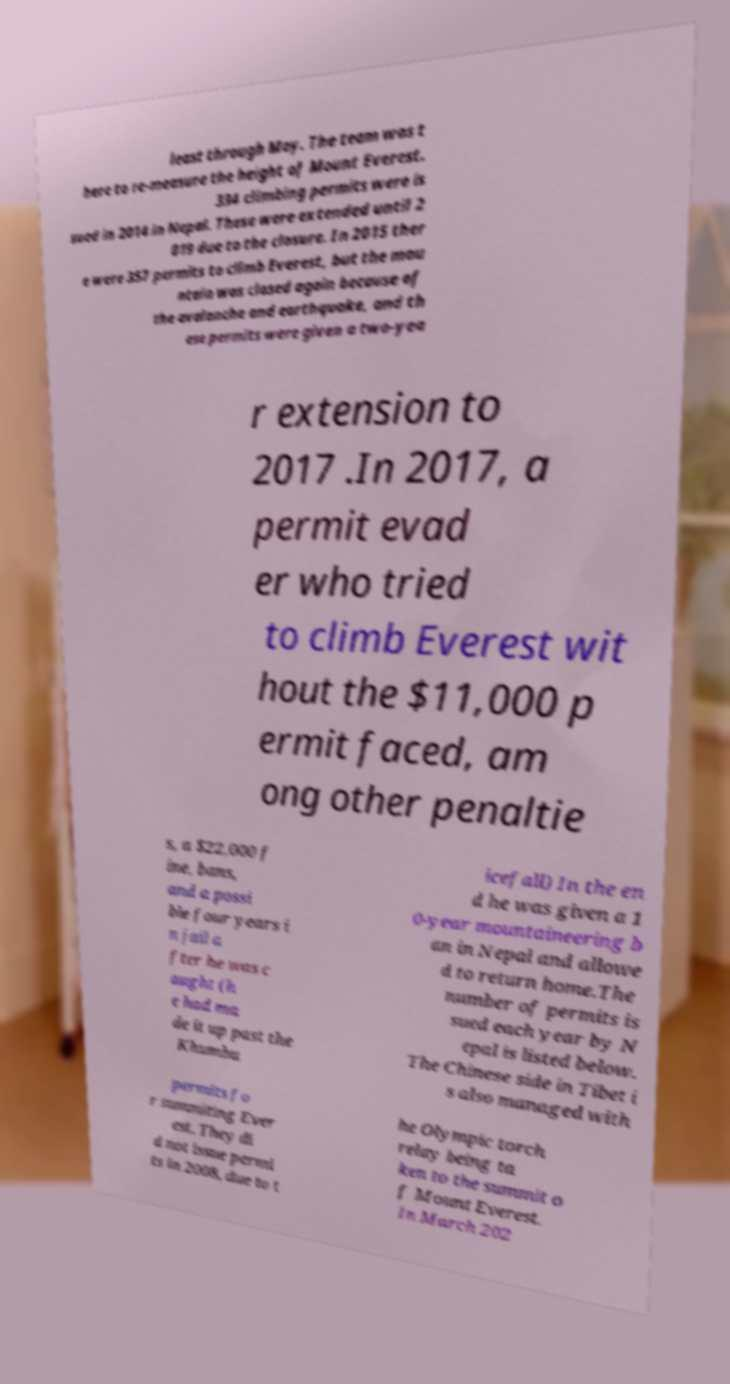Please identify and transcribe the text found in this image. least through May. The team was t here to re-measure the height of Mount Everest. 334 climbing permits were is sued in 2014 in Nepal. These were extended until 2 019 due to the closure. In 2015 ther e were 357 permits to climb Everest, but the mou ntain was closed again because of the avalanche and earthquake, and th ese permits were given a two-yea r extension to 2017 .In 2017, a permit evad er who tried to climb Everest wit hout the $11,000 p ermit faced, am ong other penaltie s, a $22,000 f ine, bans, and a possi ble four years i n jail a fter he was c aught (h e had ma de it up past the Khumbu icefall) In the en d he was given a 1 0-year mountaineering b an in Nepal and allowe d to return home.The number of permits is sued each year by N epal is listed below. The Chinese side in Tibet i s also managed with permits fo r summiting Ever est. They di d not issue permi ts in 2008, due to t he Olympic torch relay being ta ken to the summit o f Mount Everest. In March 202 